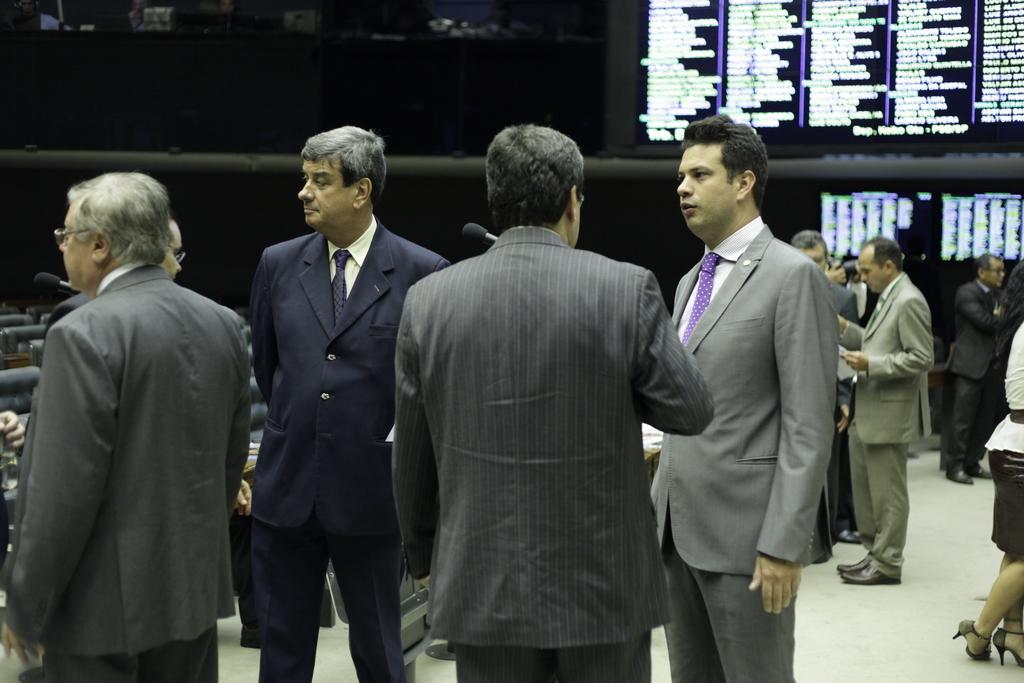Can you describe this image briefly? This picture seems to be clicked inside the hall and we can see the group of men wearing suits and standing. In the right corner we can see a person wearing white color dress and seem to be standing on the ground and we can see a microphone and the electronic devices and we can see the text on the devices. In the background we can see the chairs and many other objects. 